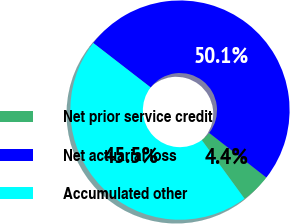Convert chart. <chart><loc_0><loc_0><loc_500><loc_500><pie_chart><fcel>Net prior service credit<fcel>Net actuarial loss<fcel>Accumulated other<nl><fcel>4.43%<fcel>50.06%<fcel>45.51%<nl></chart> 